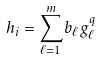<formula> <loc_0><loc_0><loc_500><loc_500>h _ { i } = \sum _ { \ell = 1 } ^ { m } b _ { \ell } g _ { \ell } ^ { q }</formula> 